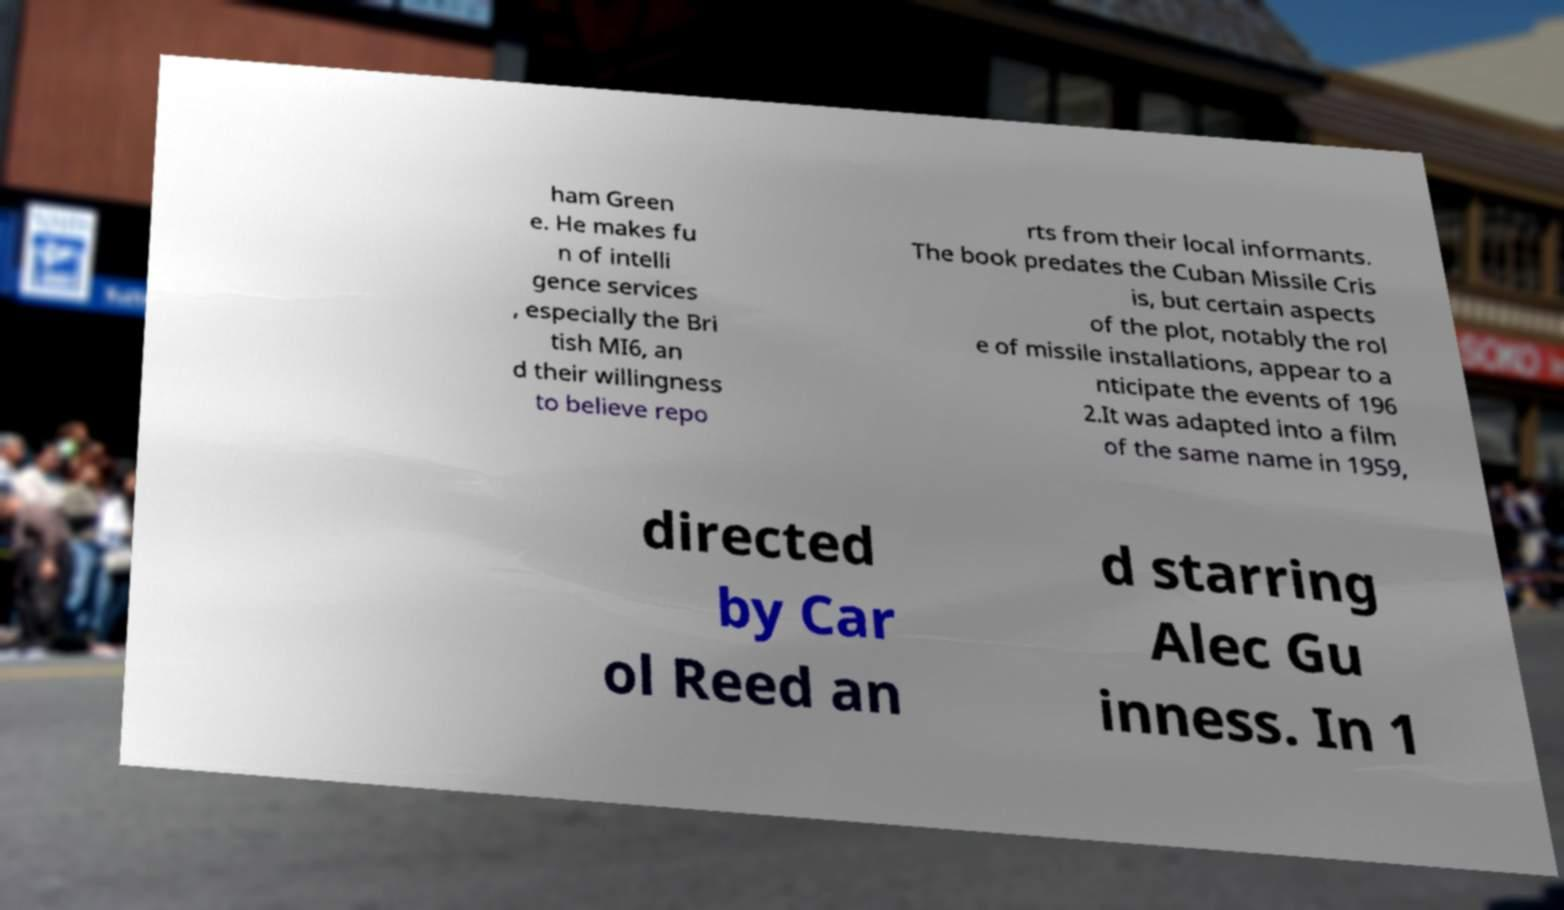What messages or text are displayed in this image? I need them in a readable, typed format. ham Green e. He makes fu n of intelli gence services , especially the Bri tish MI6, an d their willingness to believe repo rts from their local informants. The book predates the Cuban Missile Cris is, but certain aspects of the plot, notably the rol e of missile installations, appear to a nticipate the events of 196 2.It was adapted into a film of the same name in 1959, directed by Car ol Reed an d starring Alec Gu inness. In 1 